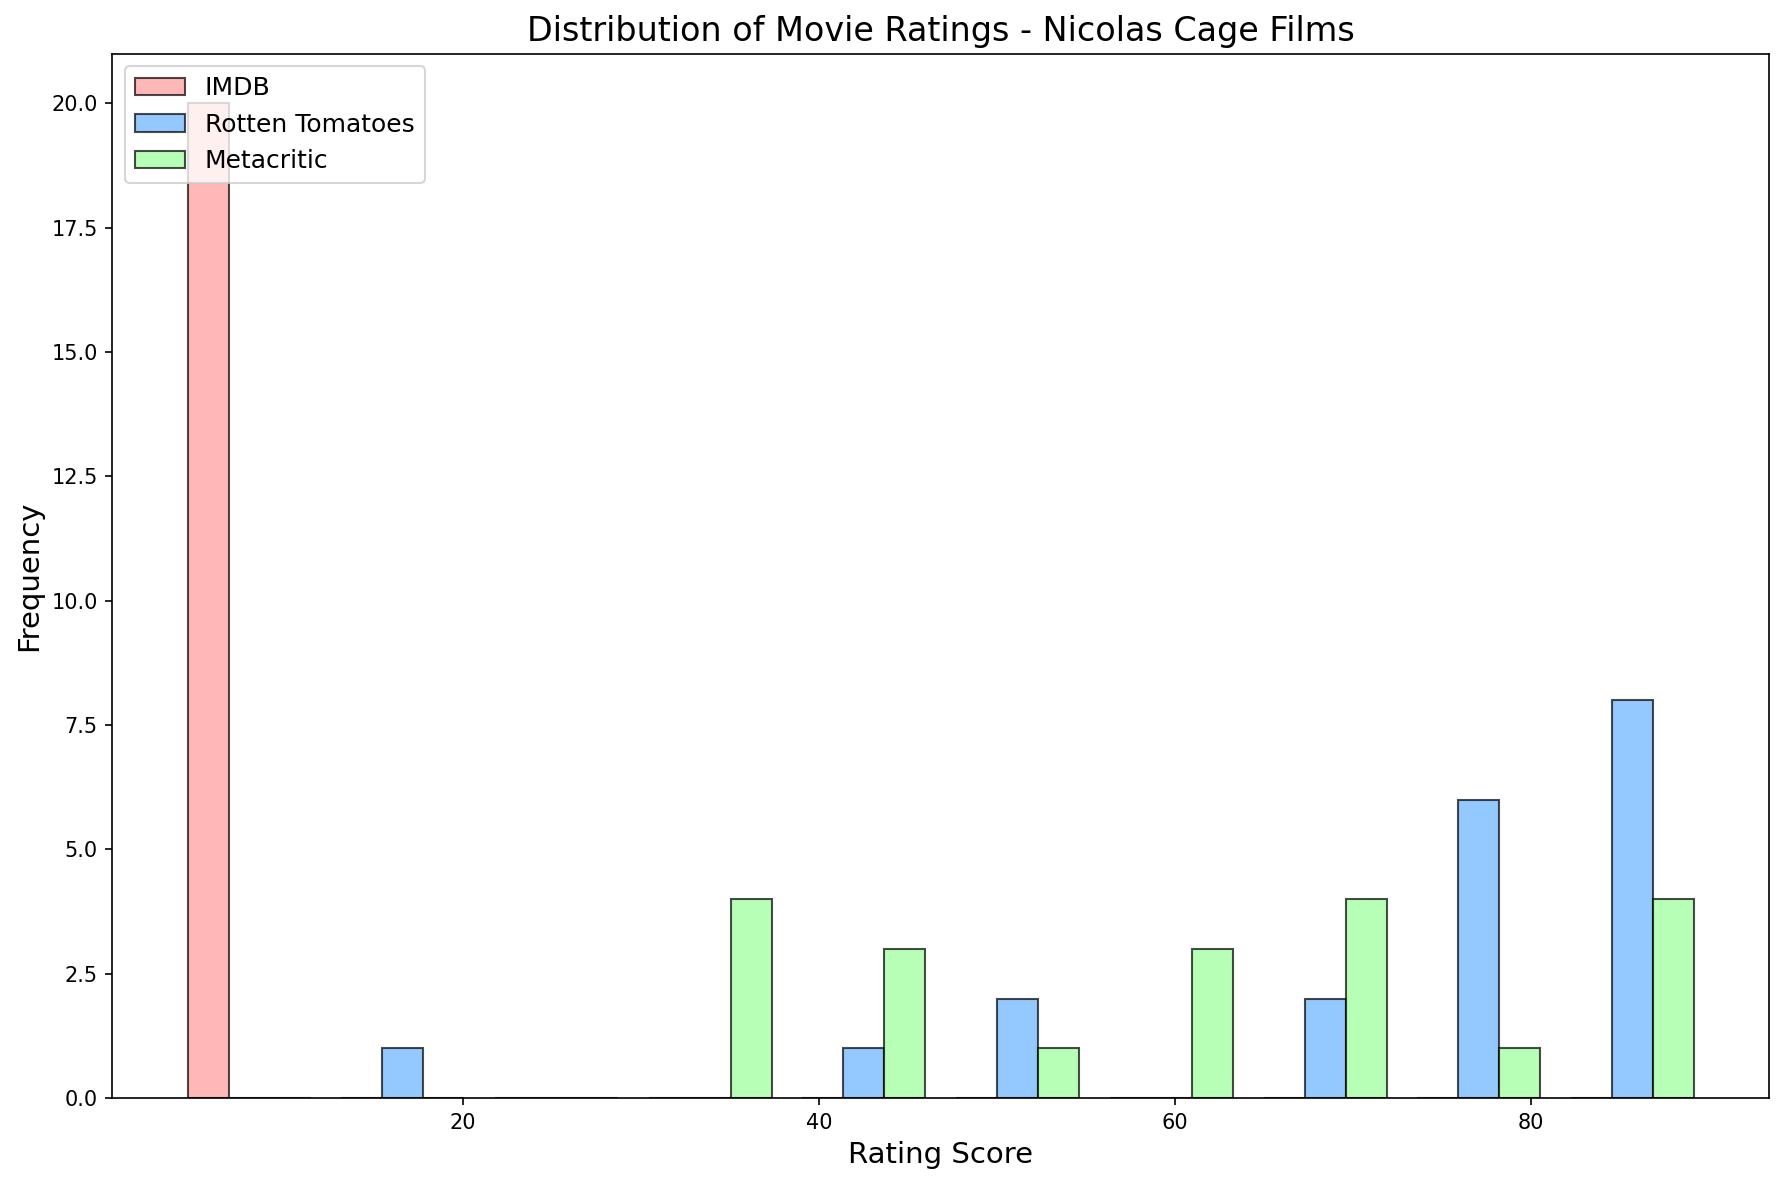What is the frequency of movies with an IMDB rating between 7 and 8? Look at the histogram for the IMDB ratings. Identify the bar that spans the range from 7 to 8 and note its height, which represents the frequency.
Answer: 9 Which review platform has the most frequent ratings in the 80-90 range? Check each histogram for the 80-90 range and compare the heights of the bars. The highest bar represents the platform with the most frequent ratings in this range.
Answer: Rotten Tomatoes What is the difference between the maximum frequency of ratings on IMDB and Metacritic? Identify the highest bars for both IMDB and Metacritic histograms. Subtract the height of the tallest Metacritic bar from the height of the tallest IMDB bar.
Answer: 1 Which platform shows the least frequency of ratings below 40? Examine the histogram bars for ratings below 40 on each platform and find the one with the shortest bar(s).
Answer: IMDB What range does the Rotten Tomatoes Audience Score’s highest frequency rating fall in? Identify the tallest bar in the Rotten Tomatoes histogram and observe the rating range that this bar covers.
Answer: 80-90 How many platforms have their highest frequency rating in the same range? Locate the bars with the highest frequencies in each histogram. Then, check if these bars share the same rating range and count the occurrences.
Answer: 2 Which platform has the widest spread of ratings above 70? Observe the range of ratings above 70 in each histogram, noting the spread (difference between the highest and lowest rating).
Answer: Rotten Tomatoes What is the combined frequency of movies with Metacritic scores in the 30-40 range and Rotten Tomatoes scores in the 55-65 range? Identify the frequencies in the 30–40 range in the Metacritic histogram and the 55-65 range in the Rotten Tomatoes histogram. Sum these frequencies.
Answer: 3 